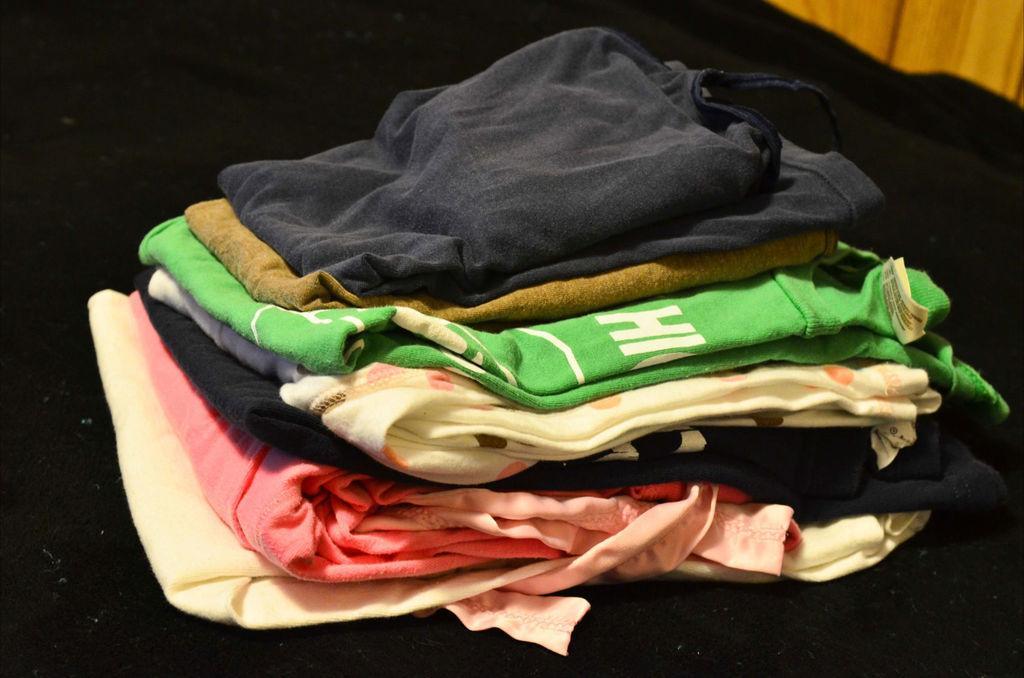How would you summarize this image in a sentence or two? In this picture I can see clothes on an object. 